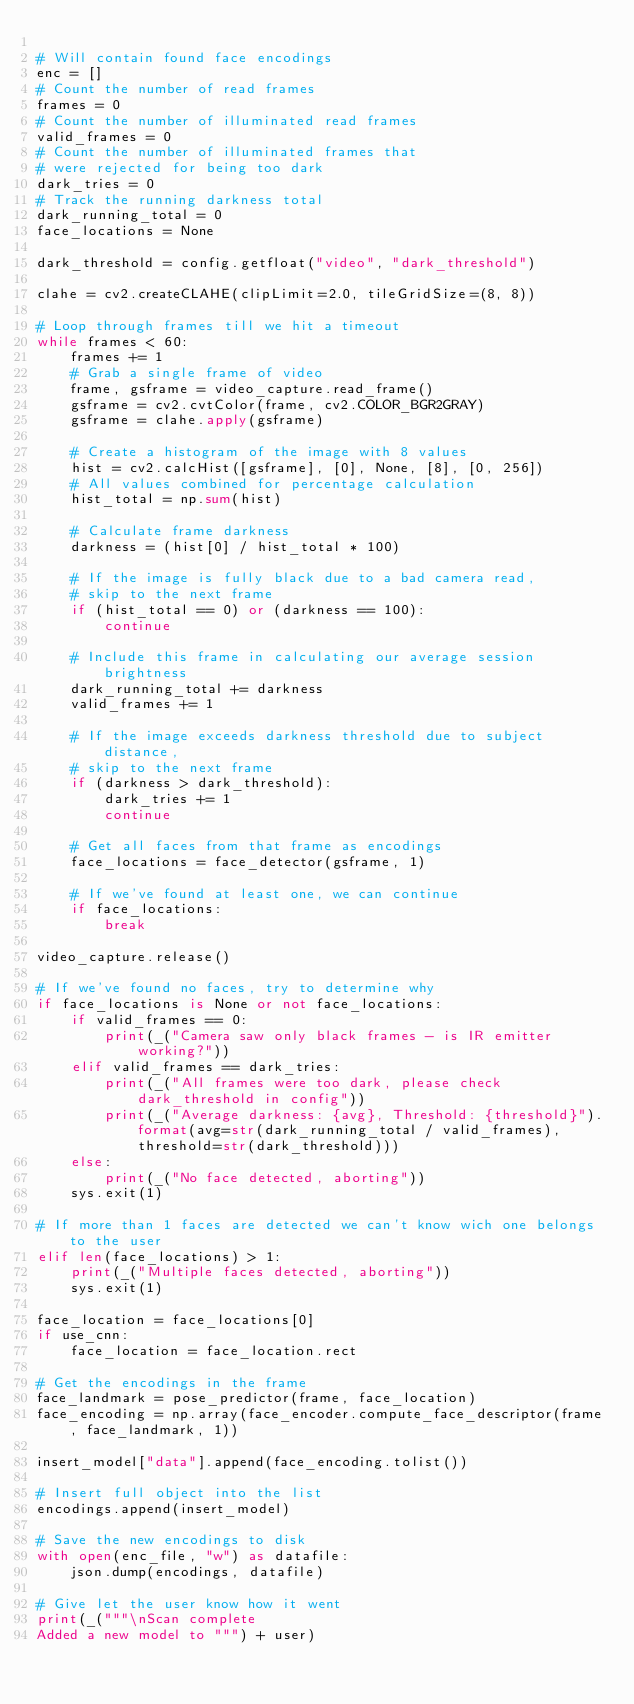<code> <loc_0><loc_0><loc_500><loc_500><_Python_>
# Will contain found face encodings
enc = []
# Count the number of read frames
frames = 0
# Count the number of illuminated read frames
valid_frames = 0
# Count the number of illuminated frames that
# were rejected for being too dark
dark_tries = 0
# Track the running darkness total
dark_running_total = 0
face_locations = None

dark_threshold = config.getfloat("video", "dark_threshold")

clahe = cv2.createCLAHE(clipLimit=2.0, tileGridSize=(8, 8))

# Loop through frames till we hit a timeout
while frames < 60:
	frames += 1
	# Grab a single frame of video
	frame, gsframe = video_capture.read_frame()
	gsframe = cv2.cvtColor(frame, cv2.COLOR_BGR2GRAY)
	gsframe = clahe.apply(gsframe)

	# Create a histogram of the image with 8 values
	hist = cv2.calcHist([gsframe], [0], None, [8], [0, 256])
	# All values combined for percentage calculation
	hist_total = np.sum(hist)

	# Calculate frame darkness
	darkness = (hist[0] / hist_total * 100)

	# If the image is fully black due to a bad camera read,
	# skip to the next frame
	if (hist_total == 0) or (darkness == 100):
		continue

	# Include this frame in calculating our average session brightness
	dark_running_total += darkness
	valid_frames += 1

	# If the image exceeds darkness threshold due to subject distance,
	# skip to the next frame
	if (darkness > dark_threshold):
		dark_tries += 1
		continue

	# Get all faces from that frame as encodings
	face_locations = face_detector(gsframe, 1)

	# If we've found at least one, we can continue
	if face_locations:
		break

video_capture.release()

# If we've found no faces, try to determine why
if face_locations is None or not face_locations:
	if valid_frames == 0:
		print(_("Camera saw only black frames - is IR emitter working?"))
	elif valid_frames == dark_tries:
		print(_("All frames were too dark, please check dark_threshold in config"))
		print(_("Average darkness: {avg}, Threshold: {threshold}").format(avg=str(dark_running_total / valid_frames), threshold=str(dark_threshold)))
	else:
		print(_("No face detected, aborting"))
	sys.exit(1)

# If more than 1 faces are detected we can't know wich one belongs to the user
elif len(face_locations) > 1:
	print(_("Multiple faces detected, aborting"))
	sys.exit(1)

face_location = face_locations[0]
if use_cnn:
	face_location = face_location.rect

# Get the encodings in the frame
face_landmark = pose_predictor(frame, face_location)
face_encoding = np.array(face_encoder.compute_face_descriptor(frame, face_landmark, 1))

insert_model["data"].append(face_encoding.tolist())

# Insert full object into the list
encodings.append(insert_model)

# Save the new encodings to disk
with open(enc_file, "w") as datafile:
	json.dump(encodings, datafile)

# Give let the user know how it went
print(_("""\nScan complete
Added a new model to """) + user)
</code> 